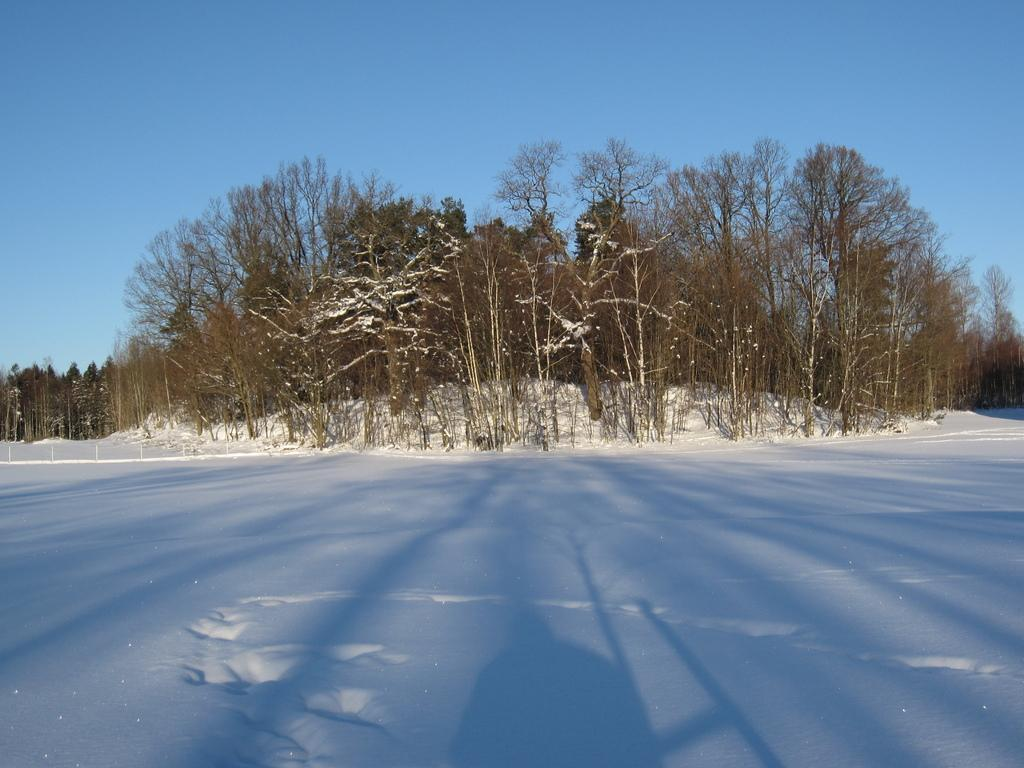What type of landscape is depicted in the image? The image shows an open land. What is covering the open land in the image? The open land is covered with snow. What can be seen in the background of the image? There are trees in the background of the image. What is the condition of the sky in the image? The sky is clear and visible in the background. Are there any waves visible in the image? There are no waves present in the image, as it depicts an open land covered with snow and does not show any bodies of water. 